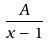Convert formula to latex. <formula><loc_0><loc_0><loc_500><loc_500>\frac { A } { x - 1 }</formula> 